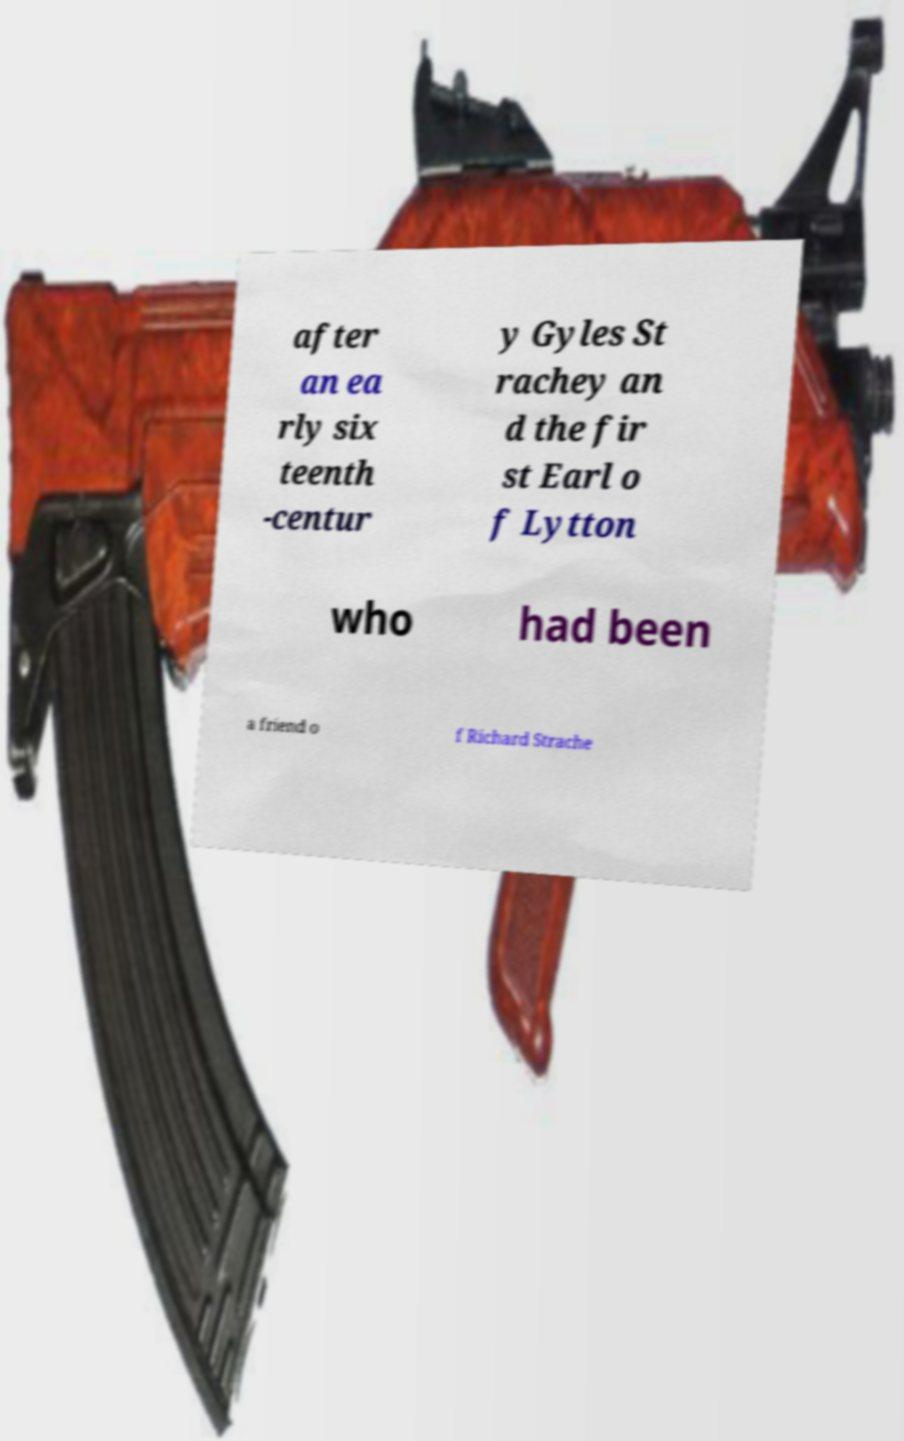Can you accurately transcribe the text from the provided image for me? after an ea rly six teenth -centur y Gyles St rachey an d the fir st Earl o f Lytton who had been a friend o f Richard Strache 